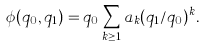Convert formula to latex. <formula><loc_0><loc_0><loc_500><loc_500>\phi ( q _ { 0 } , q _ { 1 } ) = q _ { 0 } \sum _ { k \geq 1 } a _ { k } ( q _ { 1 } / q _ { 0 } ) ^ { k } .</formula> 